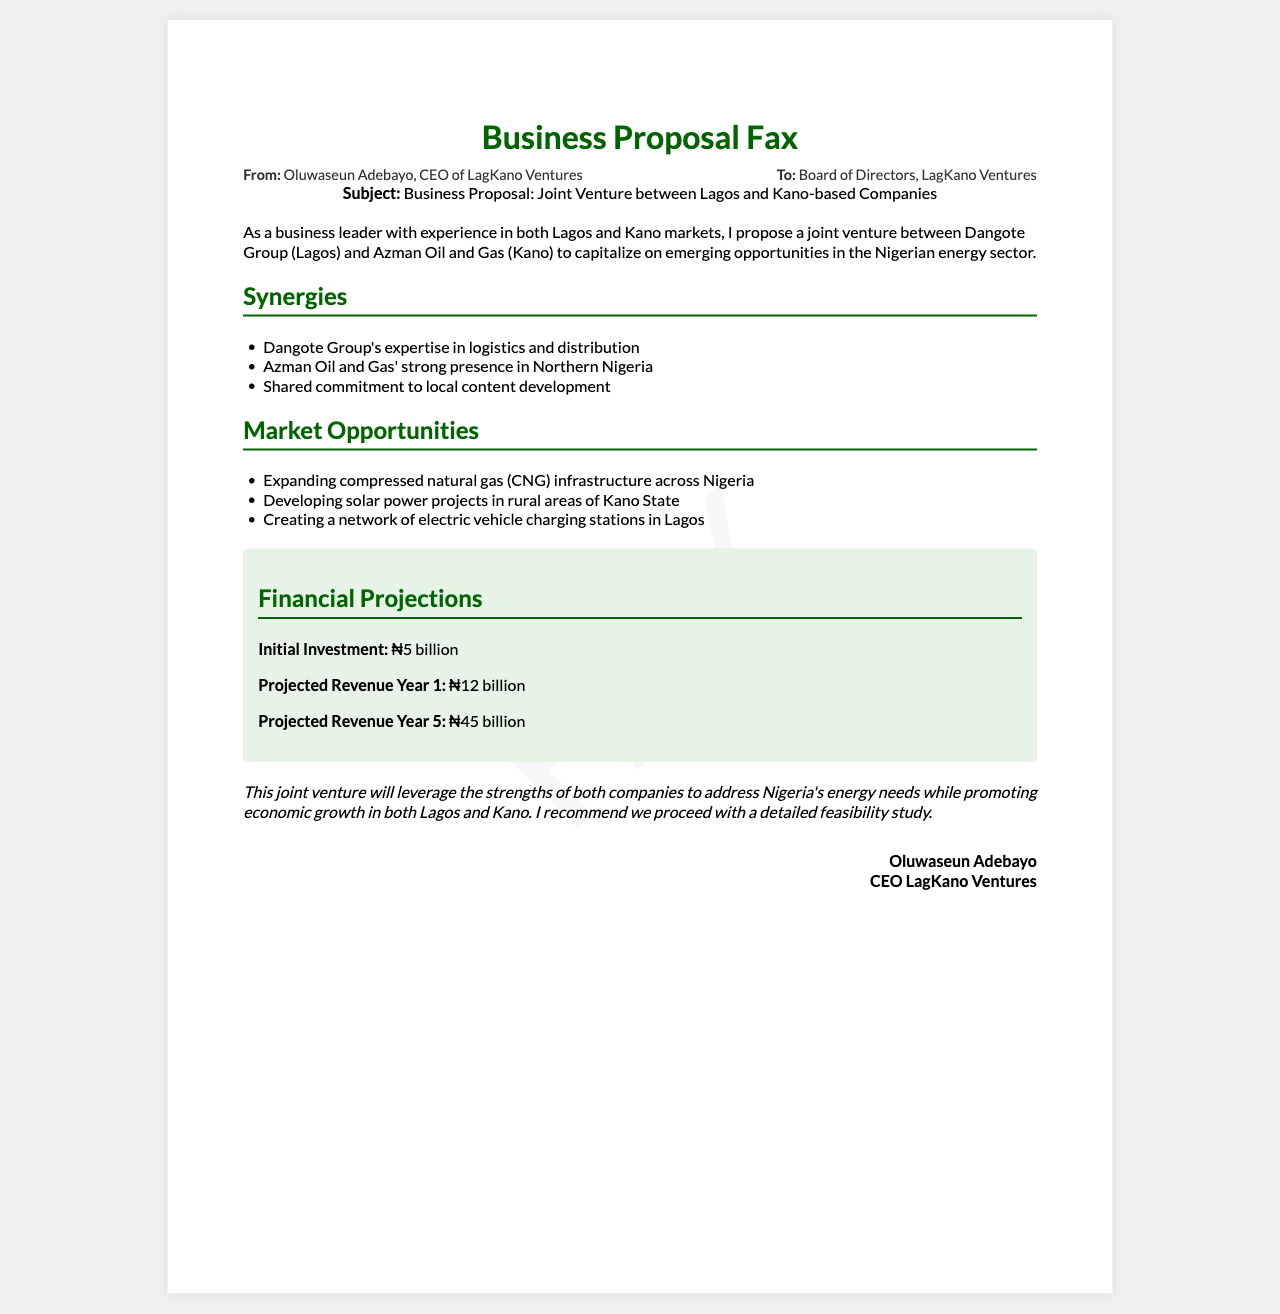What is the subject of the fax? The subject of the fax is explicitly stated in the document.
Answer: Business Proposal: Joint Venture between Lagos and Kano-based Companies Who is the CEO of LagKano Ventures? The document lists the CEO of LagKano Ventures in the signature section.
Answer: Oluwaseun Adebayo What is the initial investment amount? The initial investment is detailed in the financial projections section of the document.
Answer: ₦5 billion Which two companies are mentioned in the proposal? The proposal specifically names the companies involved in the joint venture.
Answer: Dangote Group and Azman Oil and Gas What is one market opportunity listed? The document includes several market opportunities, and any could be cited, but one example is sufficient.
Answer: Expanding compressed natural gas (CNG) infrastructure across Nigeria What is the projected revenue in Year 5? The projected revenue for Year 5 is mentioned in the financial section.
Answer: ₦45 billion What commitment do both companies share? The document outlines a specific shared commitment in the synergies section.
Answer: Local content development What is the destination of the fax? The destination of the fax is specified in the header information.
Answer: Board of Directors, LagKano Ventures 